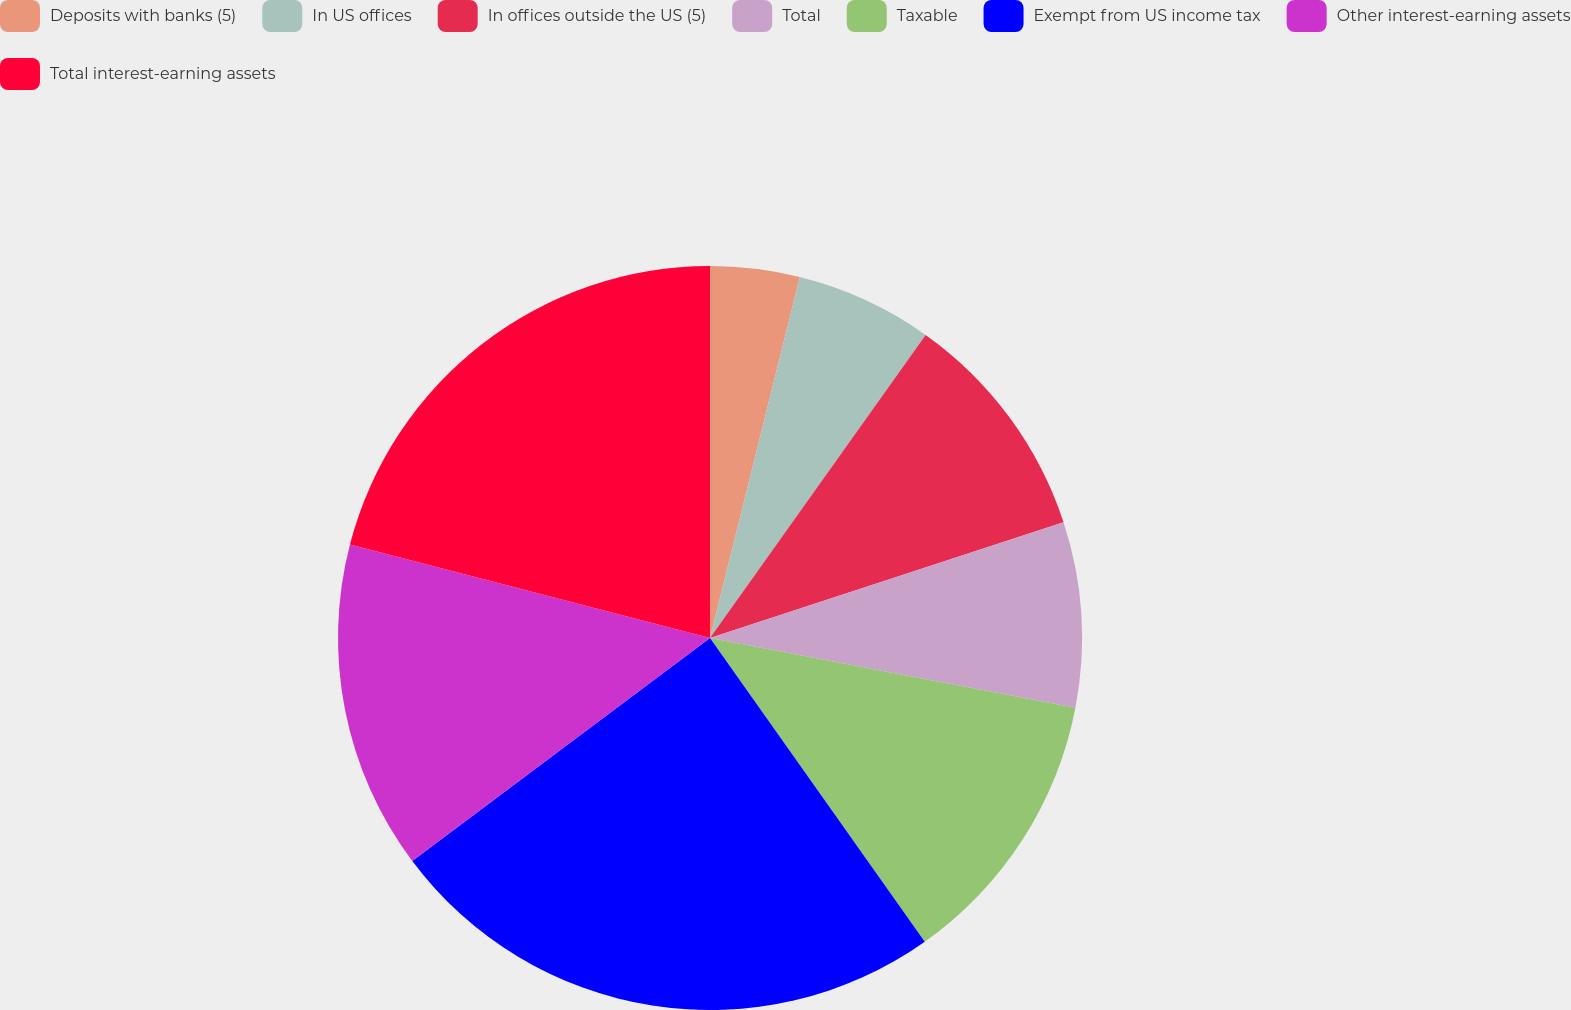Convert chart to OTSL. <chart><loc_0><loc_0><loc_500><loc_500><pie_chart><fcel>Deposits with banks (5)<fcel>In US offices<fcel>In offices outside the US (5)<fcel>Total<fcel>Taxable<fcel>Exempt from US income tax<fcel>Other interest-earning assets<fcel>Total interest-earning assets<nl><fcel>3.88%<fcel>5.96%<fcel>10.12%<fcel>8.04%<fcel>12.2%<fcel>24.56%<fcel>14.28%<fcel>20.95%<nl></chart> 